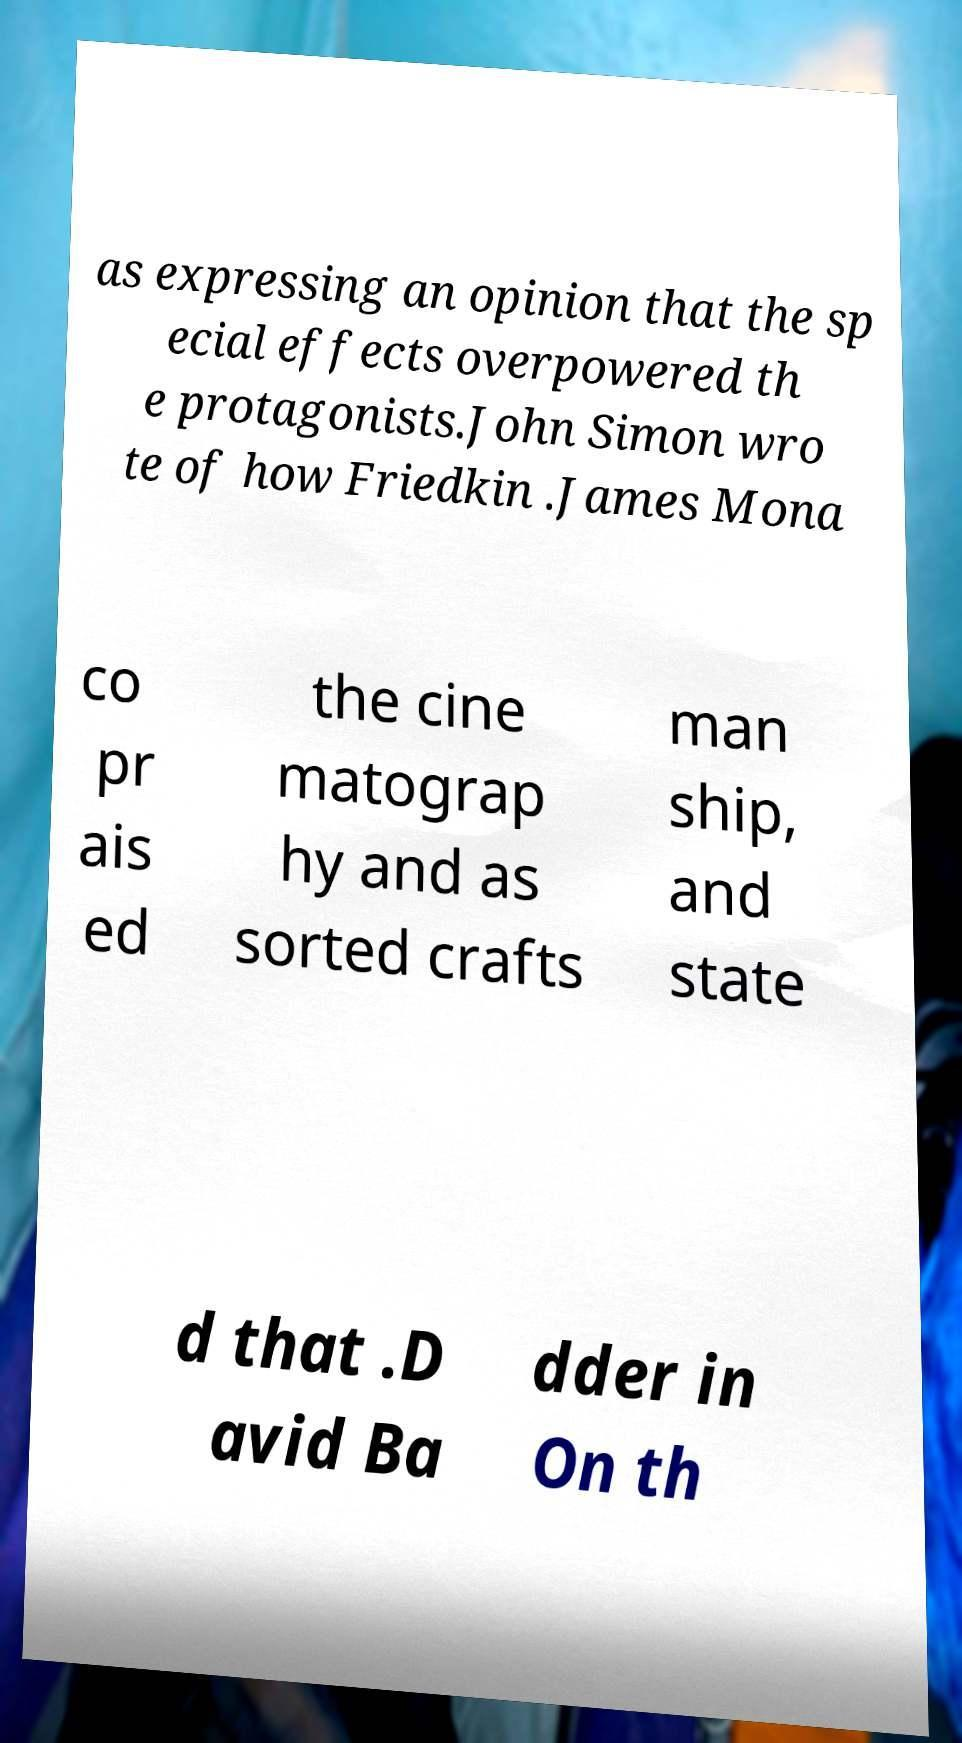I need the written content from this picture converted into text. Can you do that? as expressing an opinion that the sp ecial effects overpowered th e protagonists.John Simon wro te of how Friedkin .James Mona co pr ais ed the cine matograp hy and as sorted crafts man ship, and state d that .D avid Ba dder in On th 